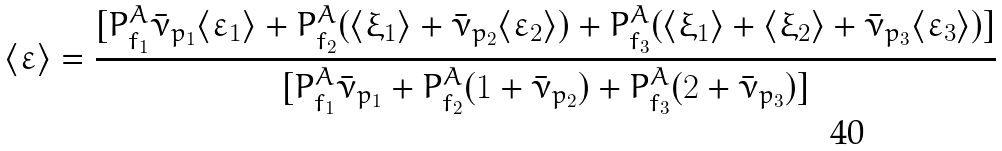Convert formula to latex. <formula><loc_0><loc_0><loc_500><loc_500>\langle \varepsilon \rangle = \frac { [ P _ { f _ { 1 } } ^ { A } { \bar { \nu } } _ { p _ { 1 } } \langle \varepsilon _ { 1 } \rangle + P _ { f _ { 2 } } ^ { A } ( \langle \xi _ { 1 } \rangle + { \bar { \nu } } _ { p _ { 2 } } \langle \varepsilon _ { 2 } \rangle ) + P _ { f _ { 3 } } ^ { A } ( \langle \xi _ { 1 } \rangle + \langle \xi _ { 2 } \rangle + { \bar { \nu } } _ { p _ { 3 } } \langle \varepsilon _ { 3 } \rangle ) ] } { [ P _ { f _ { 1 } } ^ { A } { \bar { \nu } } _ { p _ { 1 } } + P _ { f _ { 2 } } ^ { A } ( 1 + { \bar { \nu } } _ { p _ { 2 } } ) + P _ { f _ { 3 } } ^ { A } ( 2 + { \bar { \nu } } _ { p _ { 3 } } ) ] }</formula> 